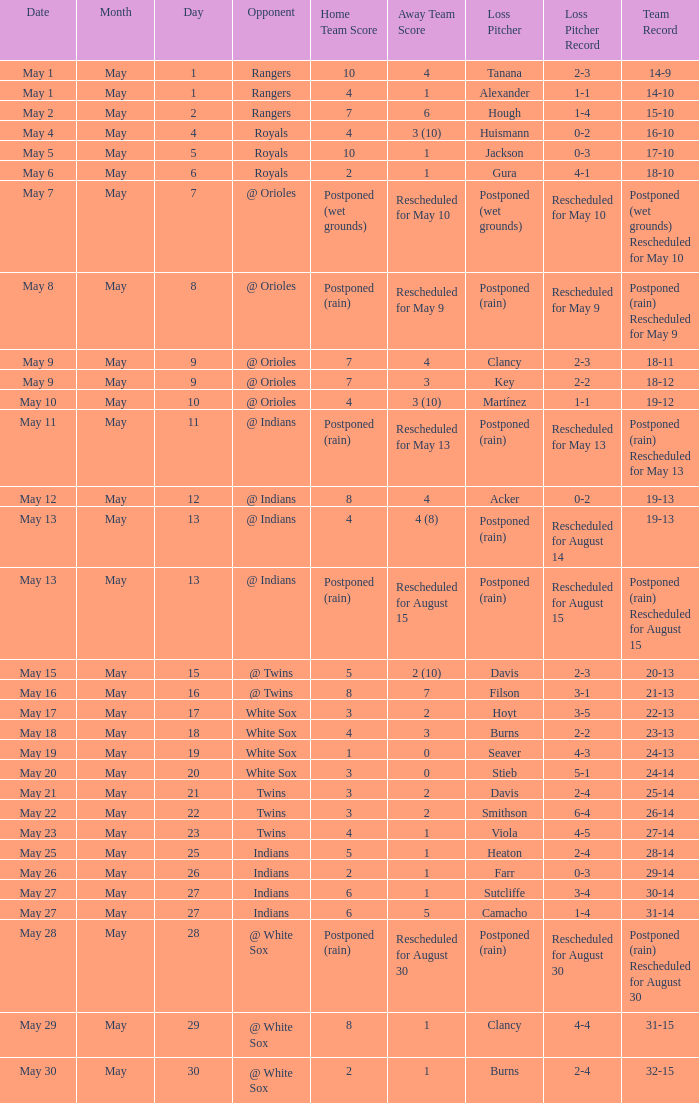What was the record at the game against the Indians with a loss of Camacho (1-4)? 31-14. 